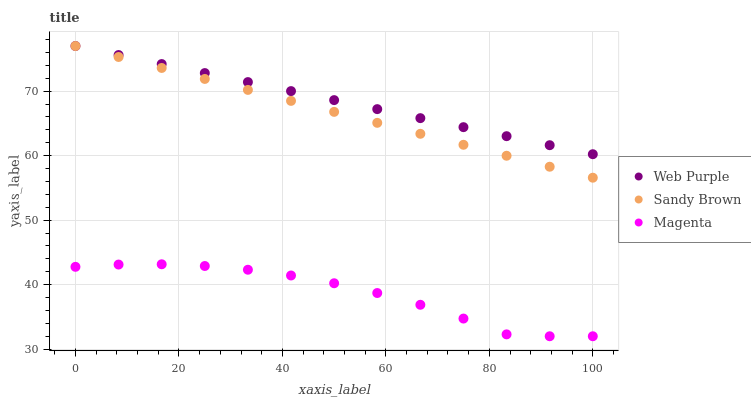Does Magenta have the minimum area under the curve?
Answer yes or no. Yes. Does Web Purple have the maximum area under the curve?
Answer yes or no. Yes. Does Sandy Brown have the minimum area under the curve?
Answer yes or no. No. Does Sandy Brown have the maximum area under the curve?
Answer yes or no. No. Is Sandy Brown the smoothest?
Answer yes or no. Yes. Is Magenta the roughest?
Answer yes or no. Yes. Is Magenta the smoothest?
Answer yes or no. No. Is Sandy Brown the roughest?
Answer yes or no. No. Does Magenta have the lowest value?
Answer yes or no. Yes. Does Sandy Brown have the lowest value?
Answer yes or no. No. Does Sandy Brown have the highest value?
Answer yes or no. Yes. Does Magenta have the highest value?
Answer yes or no. No. Is Magenta less than Sandy Brown?
Answer yes or no. Yes. Is Sandy Brown greater than Magenta?
Answer yes or no. Yes. Does Sandy Brown intersect Web Purple?
Answer yes or no. Yes. Is Sandy Brown less than Web Purple?
Answer yes or no. No. Is Sandy Brown greater than Web Purple?
Answer yes or no. No. Does Magenta intersect Sandy Brown?
Answer yes or no. No. 